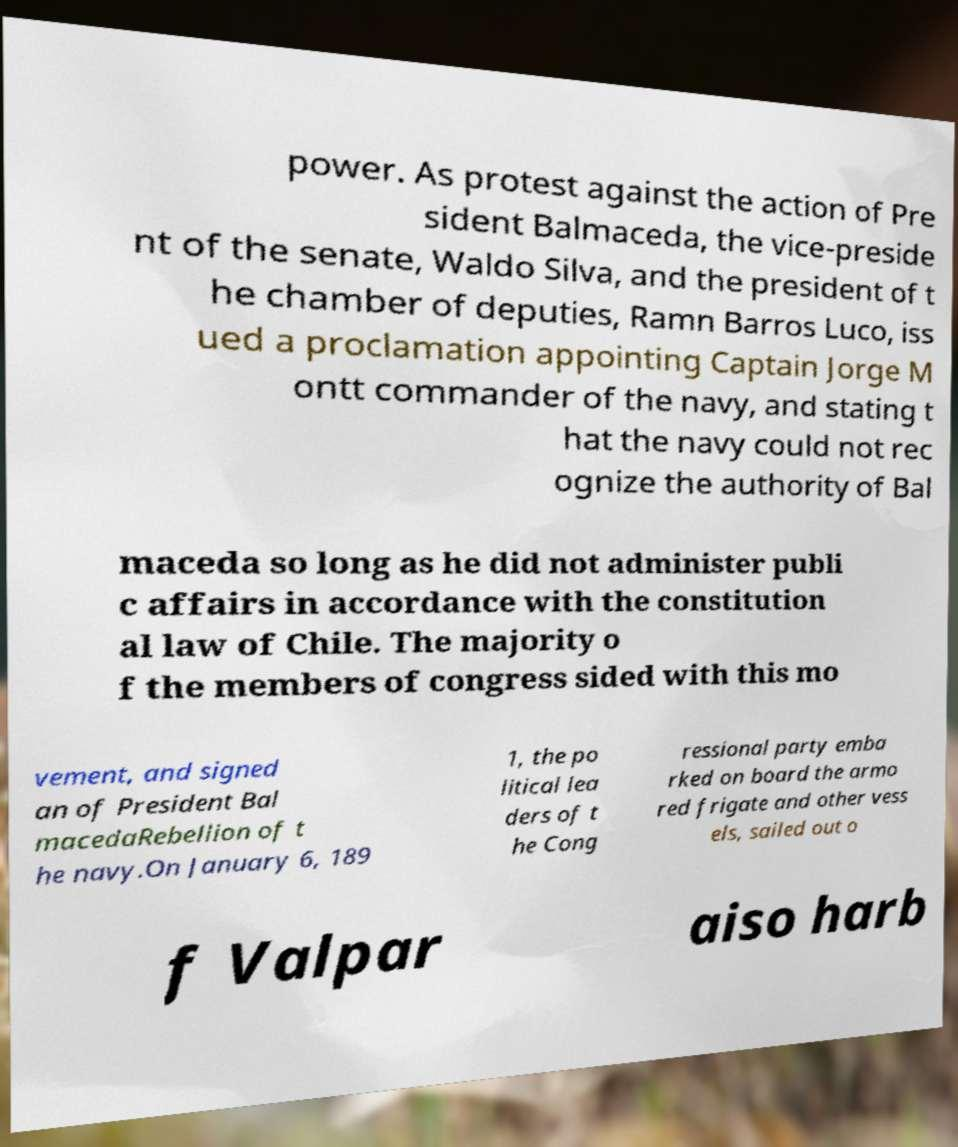There's text embedded in this image that I need extracted. Can you transcribe it verbatim? power. As protest against the action of Pre sident Balmaceda, the vice-preside nt of the senate, Waldo Silva, and the president of t he chamber of deputies, Ramn Barros Luco, iss ued a proclamation appointing Captain Jorge M ontt commander of the navy, and stating t hat the navy could not rec ognize the authority of Bal maceda so long as he did not administer publi c affairs in accordance with the constitution al law of Chile. The majority o f the members of congress sided with this mo vement, and signed an of President Bal macedaRebellion of t he navy.On January 6, 189 1, the po litical lea ders of t he Cong ressional party emba rked on board the armo red frigate and other vess els, sailed out o f Valpar aiso harb 